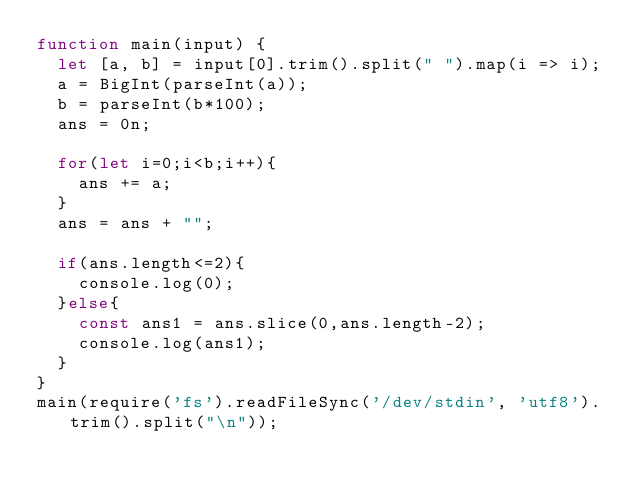<code> <loc_0><loc_0><loc_500><loc_500><_JavaScript_>function main(input) {
  let [a, b] = input[0].trim().split(" ").map(i => i);
  a = BigInt(parseInt(a));
  b = parseInt(b*100);
  ans = 0n;

  for(let i=0;i<b;i++){
    ans += a;
  }
  ans = ans + "";

  if(ans.length<=2){
    console.log(0);
  }else{
    const ans1 = ans.slice(0,ans.length-2);
    console.log(ans1);
  }
}
main(require('fs').readFileSync('/dev/stdin', 'utf8').trim().split("\n"));</code> 